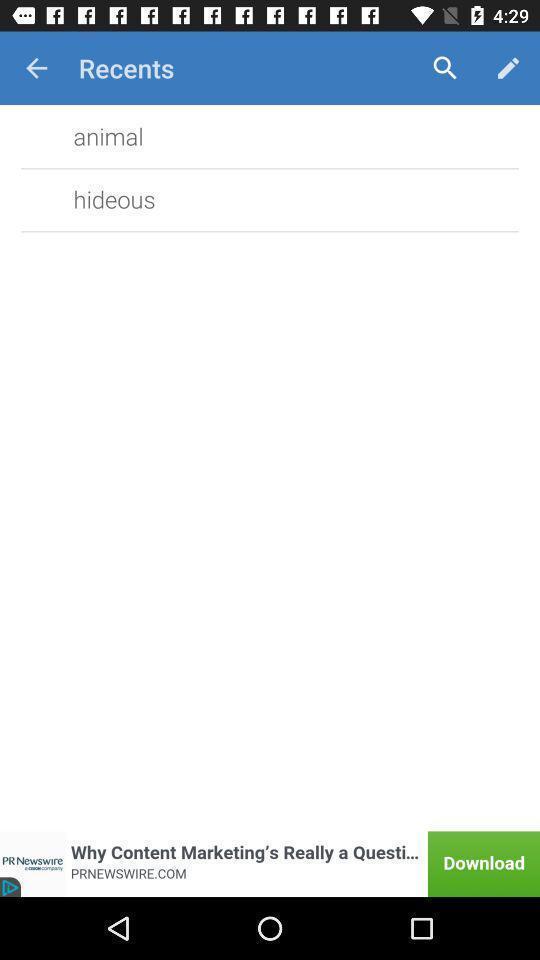Tell me what you see in this picture. Search page with options. 